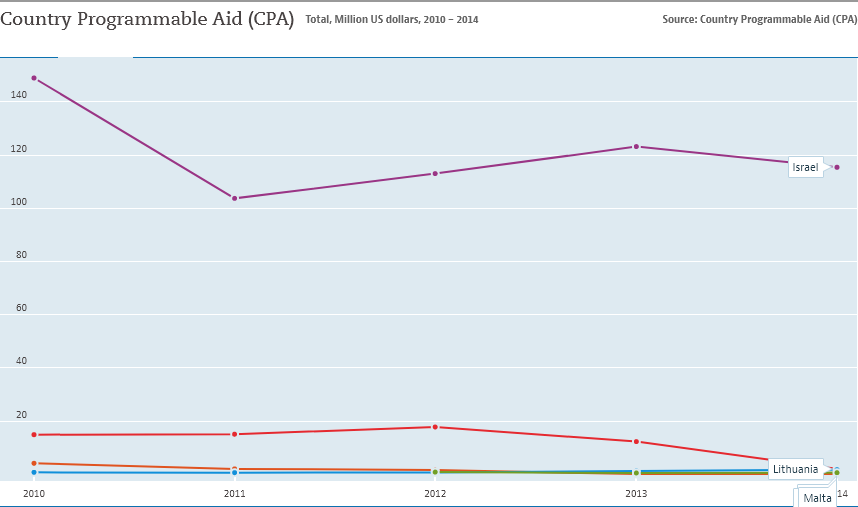Draw attention to some important aspects in this diagram. The country with the highest Cost Per Action (CPA) value is Israel, with a peak value that exceeds 140. The Country Programmable Aid (CPA) value in Israel was greater than the total CPA value of all other countries in 2012. 